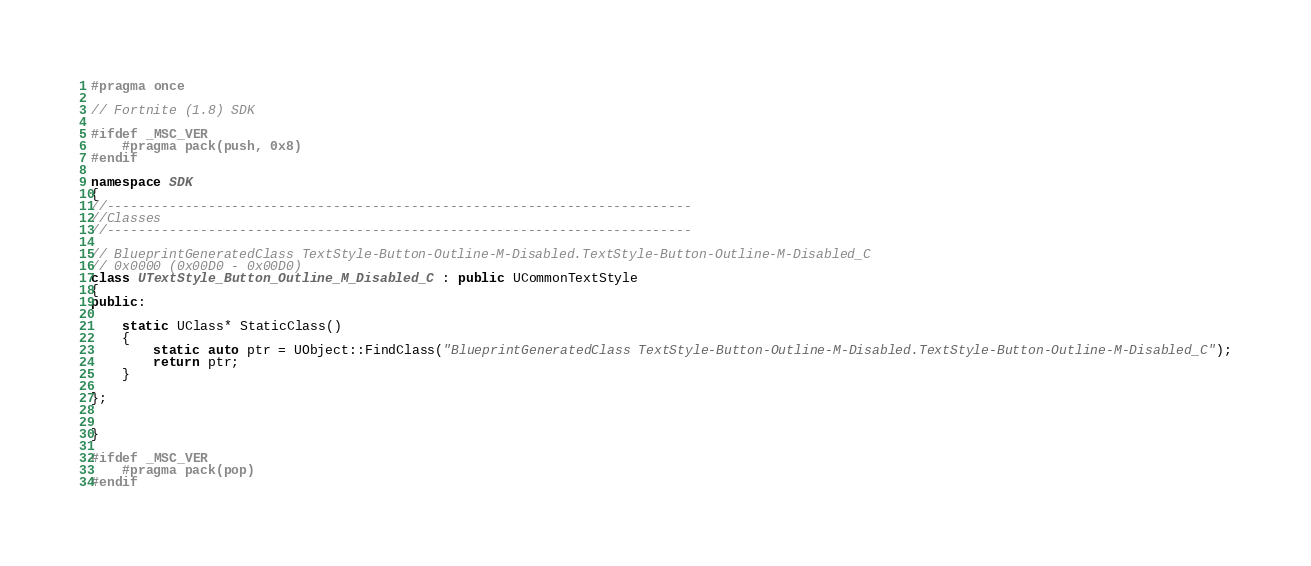Convert code to text. <code><loc_0><loc_0><loc_500><loc_500><_C++_>#pragma once

// Fortnite (1.8) SDK

#ifdef _MSC_VER
	#pragma pack(push, 0x8)
#endif

namespace SDK
{
//---------------------------------------------------------------------------
//Classes
//---------------------------------------------------------------------------

// BlueprintGeneratedClass TextStyle-Button-Outline-M-Disabled.TextStyle-Button-Outline-M-Disabled_C
// 0x0000 (0x00D0 - 0x00D0)
class UTextStyle_Button_Outline_M_Disabled_C : public UCommonTextStyle
{
public:

	static UClass* StaticClass()
	{
		static auto ptr = UObject::FindClass("BlueprintGeneratedClass TextStyle-Button-Outline-M-Disabled.TextStyle-Button-Outline-M-Disabled_C");
		return ptr;
	}

};


}

#ifdef _MSC_VER
	#pragma pack(pop)
#endif
</code> 